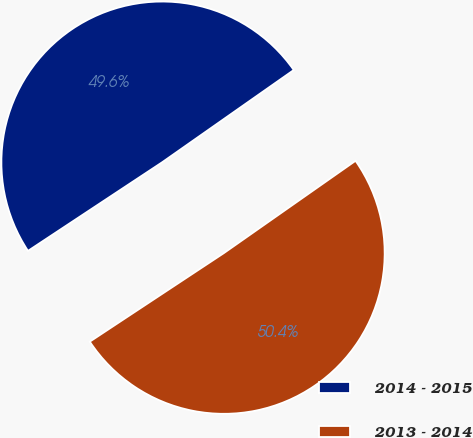Convert chart to OTSL. <chart><loc_0><loc_0><loc_500><loc_500><pie_chart><fcel>2014 - 2015<fcel>2013 - 2014<nl><fcel>49.56%<fcel>50.44%<nl></chart> 